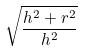Convert formula to latex. <formula><loc_0><loc_0><loc_500><loc_500>\sqrt { \frac { h ^ { 2 } + r ^ { 2 } } { h ^ { 2 } } }</formula> 